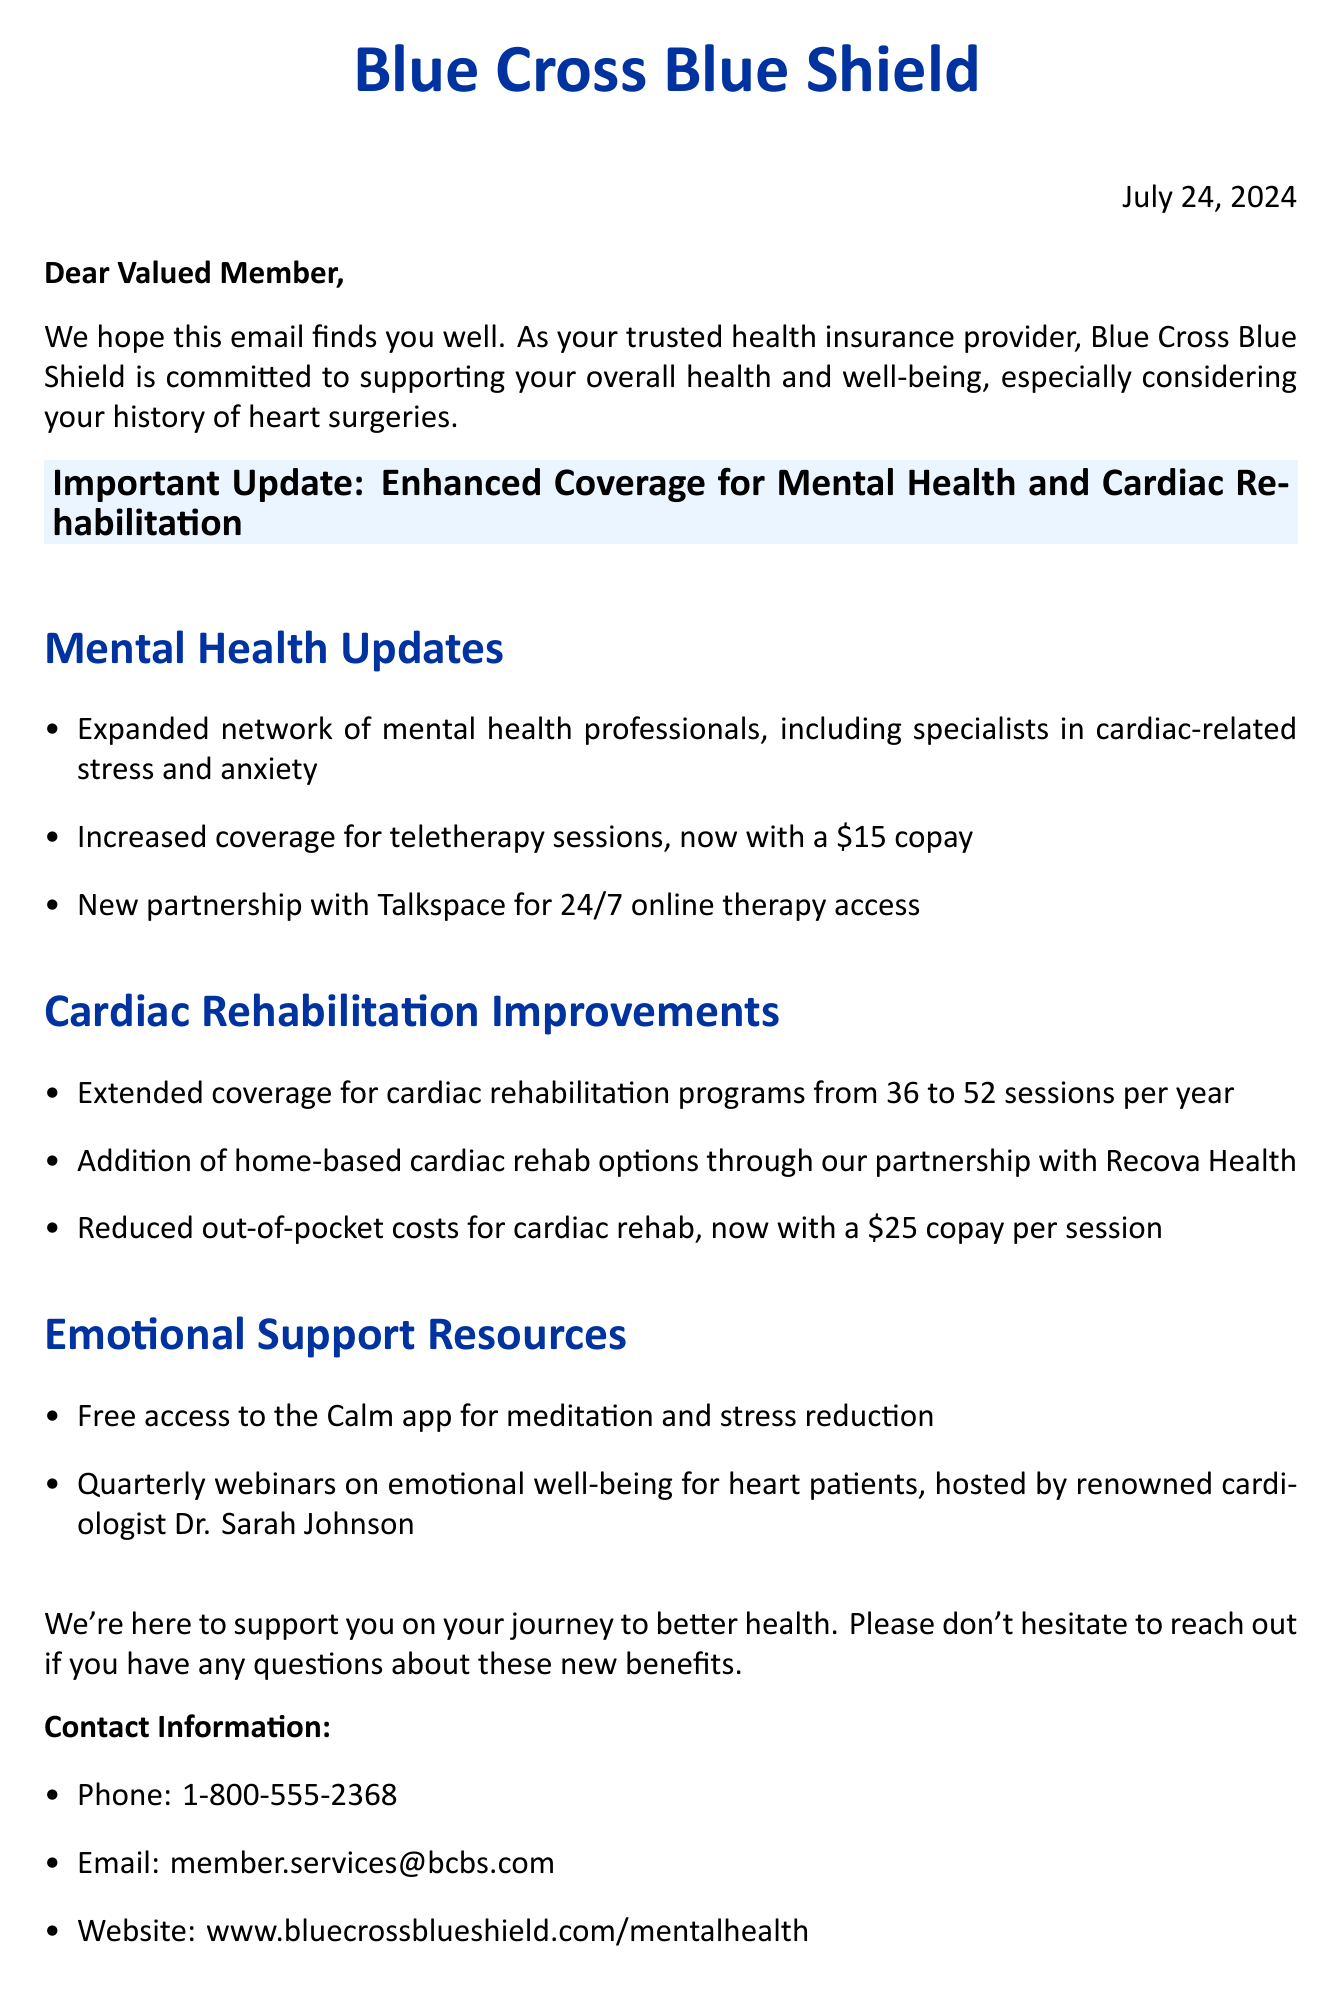What is the name of the health insurance provider? The document states that the health insurance provider is Blue Cross Blue Shield.
Answer: Blue Cross Blue Shield How many teletherapy sessions copay has been increased to? The email mentions that the copay for teletherapy sessions is now $15.
Answer: $15 What is the new coverage limit for cardiac rehabilitation sessions per year? The update indicates that the coverage for cardiac rehabilitation programs has been extended from 36 to 52 sessions per year.
Answer: 52 sessions What app is provided for free access to members? The document states that members have free access to the Calm app for meditation and stress reduction.
Answer: Calm app Who is the host of the quarterly webinars on emotional well-being? The email mentions that the webinars are hosted by renowned cardiologist Dr. Sarah Johnson.
Answer: Dr. Sarah Johnson What is the reduced copay for cardiac rehabilitation per session? The document indicates that the copay for cardiac rehab is now $25 per session.
Answer: $25 What is the primary goal of the email? The email aims to update members about enhanced coverage for mental health and cardiac rehabilitation services.
Answer: Enhanced coverage What type of email is this document classified as? The structure and content indicate that this is an important update from a health insurance provider.
Answer: Important update email 